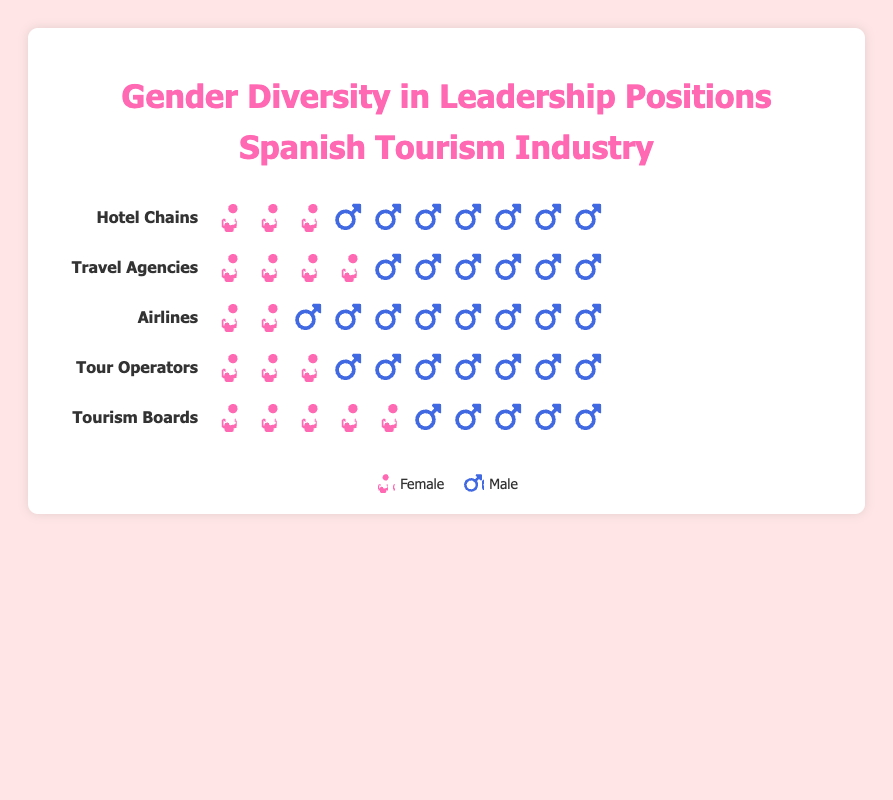What's the title of the Isotype Plot? The title is displayed prominently at the top of the plot. Reading the text at the top will give us the title.
Answer: Gender diversity in leadership positions within the Spanish tourism industry How many women are there in leadership positions within Travel Agencies? Look at the row labeled "Travel Agencies" and count the number of pink icons (female). Each icon represents one person.
Answer: 4 How many men hold leadership positions in Airlines? Find the "Airlines" row and count the number of blue icons (male). Each icon represents one person.
Answer: 8 Compare the number of female leaders in Hotel Chains and Tour Operators. Which category has more female leaders? Count the number of pink icons (female) in both "Hotel Chains" and "Tour Operators". Then compare the counts.
Answer: They have the same number: 3 each What is the gender distribution in Tourism Boards? Identify the "Tourism Boards" row and count both pink (female) and blue (male) icons and note the numbers.
Answer: 5 females and 5 males Which category has the most equal gender distribution? Look at all the categories and compare the counts of female and male icons. Find the category where the numbers of each gender are closest.
Answer: Tourism Boards What is the total number of leadership positions depicted in the plot? Sum up all the male and female icons across all categories to get the total number of leadership positions.
Answer: 50 How many more male leaders are there in Airlines compared to Travel Agencies? Find the "Airlines" and "Travel Agencies" rows, count the blue icons (male) in each, and subtract the count from Travel Agencies from the count in Airlines.
Answer: 2 more male leaders in Airlines Add the number of female leaders in Hotel Chains, Travel Agencies, and Airlines. What is the total? Count the pink icons (female) in each of the three specified categories and sum the counts.
Answer: 9 Which category has the highest number of male leaders? Look at all rows and count the blue icons (male) in each category. Identify the category with the highest count.
Answer: Airlines 